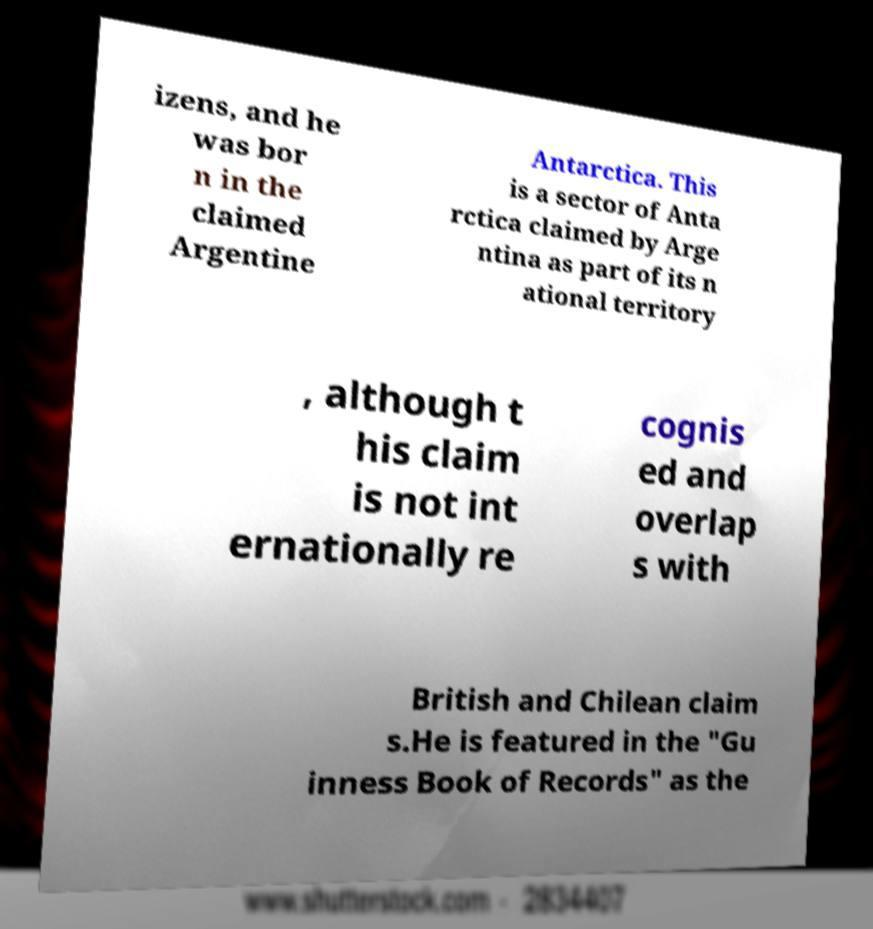There's text embedded in this image that I need extracted. Can you transcribe it verbatim? izens, and he was bor n in the claimed Argentine Antarctica. This is a sector of Anta rctica claimed by Arge ntina as part of its n ational territory , although t his claim is not int ernationally re cognis ed and overlap s with British and Chilean claim s.He is featured in the "Gu inness Book of Records" as the 